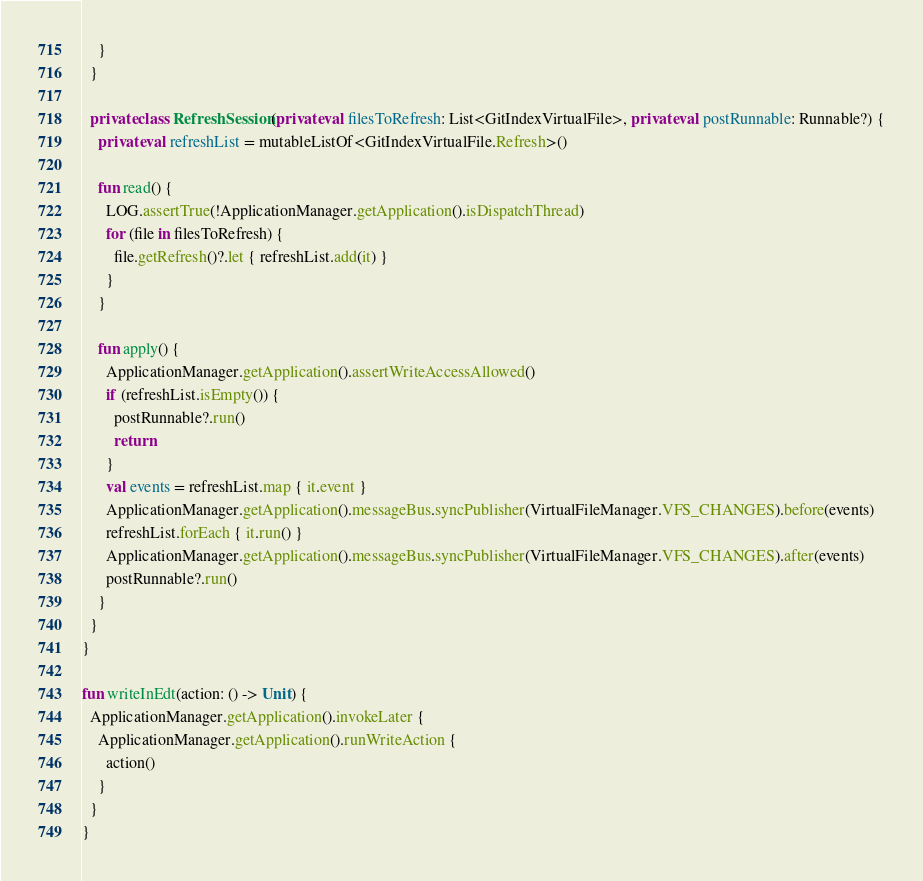<code> <loc_0><loc_0><loc_500><loc_500><_Kotlin_>    }
  }

  private class RefreshSession(private val filesToRefresh: List<GitIndexVirtualFile>, private val postRunnable: Runnable?) {
    private val refreshList = mutableListOf<GitIndexVirtualFile.Refresh>()

    fun read() {
      LOG.assertTrue(!ApplicationManager.getApplication().isDispatchThread)
      for (file in filesToRefresh) {
        file.getRefresh()?.let { refreshList.add(it) }
      }
    }

    fun apply() {
      ApplicationManager.getApplication().assertWriteAccessAllowed()
      if (refreshList.isEmpty()) {
        postRunnable?.run()
        return
      }
      val events = refreshList.map { it.event }
      ApplicationManager.getApplication().messageBus.syncPublisher(VirtualFileManager.VFS_CHANGES).before(events)
      refreshList.forEach { it.run() }
      ApplicationManager.getApplication().messageBus.syncPublisher(VirtualFileManager.VFS_CHANGES).after(events)
      postRunnable?.run()
    }
  }
}

fun writeInEdt(action: () -> Unit) {
  ApplicationManager.getApplication().invokeLater {
    ApplicationManager.getApplication().runWriteAction {
      action()
    }
  }
}</code> 